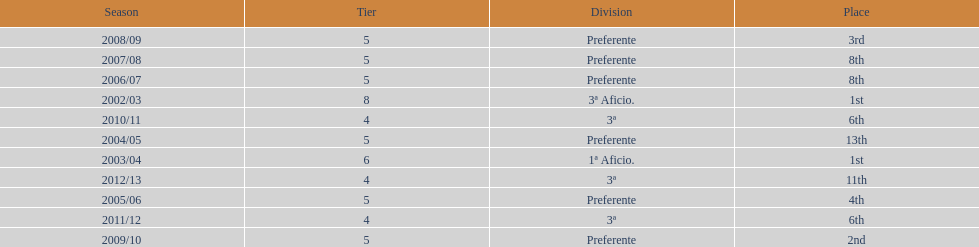What was the number of wins for preferente? 6. 